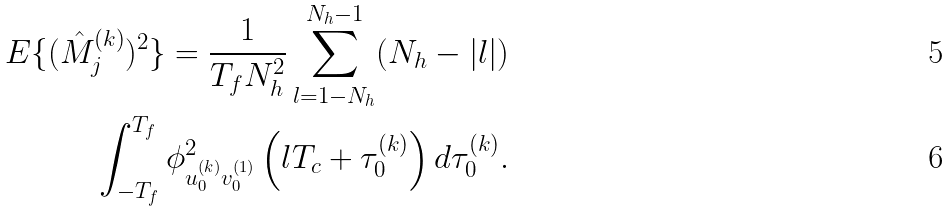<formula> <loc_0><loc_0><loc_500><loc_500>E \{ ( \hat { M } _ { j } ^ { ( k ) } ) ^ { 2 } \} = \frac { 1 } { T _ { f } N _ { h } ^ { 2 } } \sum _ { l = 1 - N _ { h } } ^ { N _ { h } - 1 } ( N _ { h } - | l | ) \\ \int _ { - T _ { f } } ^ { T _ { f } } \phi ^ { 2 } _ { u _ { 0 } ^ { ( k ) } v _ { 0 } ^ { ( 1 ) } } \left ( l T _ { c } + \tau _ { 0 } ^ { ( k ) } \right ) d \tau _ { 0 } ^ { ( k ) } .</formula> 